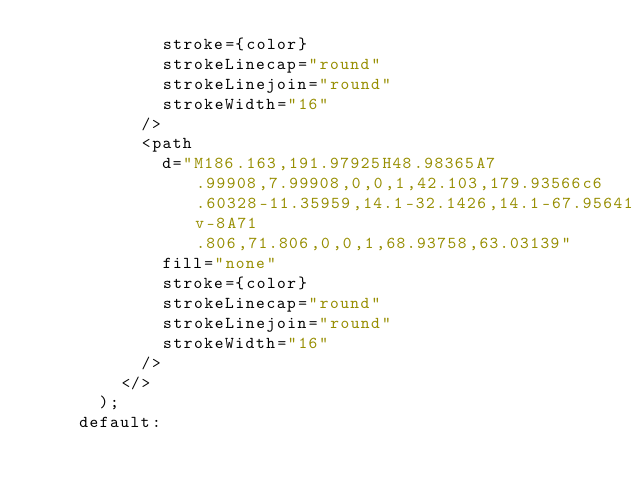Convert code to text. <code><loc_0><loc_0><loc_500><loc_500><_TypeScript_>            stroke={color}
            strokeLinecap="round"
            strokeLinejoin="round"
            strokeWidth="16"
          />
          <path
            d="M186.163,191.97925H48.98365A7.99908,7.99908,0,0,1,42.103,179.93566c6.60328-11.35959,14.1-32.1426,14.1-67.95641v-8A71.806,71.806,0,0,1,68.93758,63.03139"
            fill="none"
            stroke={color}
            strokeLinecap="round"
            strokeLinejoin="round"
            strokeWidth="16"
          />
        </>
      );
    default:</code> 